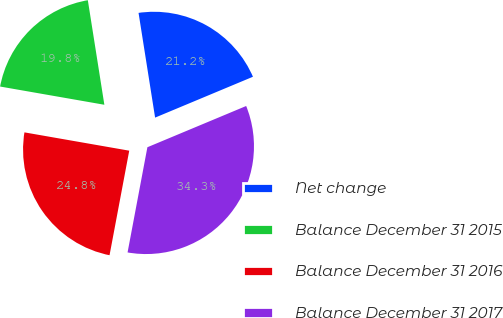Convert chart. <chart><loc_0><loc_0><loc_500><loc_500><pie_chart><fcel>Net change<fcel>Balance December 31 2015<fcel>Balance December 31 2016<fcel>Balance December 31 2017<nl><fcel>21.2%<fcel>19.75%<fcel>24.79%<fcel>34.26%<nl></chart> 